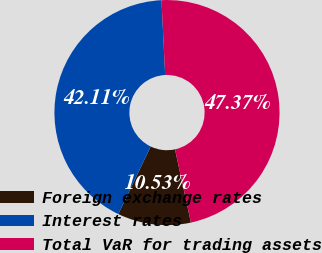<chart> <loc_0><loc_0><loc_500><loc_500><pie_chart><fcel>Foreign exchange rates<fcel>Interest rates<fcel>Total VaR for trading assets<nl><fcel>10.53%<fcel>42.11%<fcel>47.37%<nl></chart> 